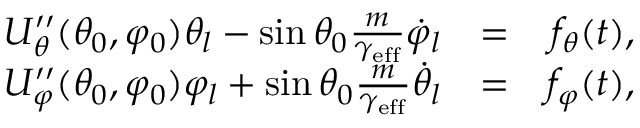<formula> <loc_0><loc_0><loc_500><loc_500>\begin{array} { r l r } { U _ { \theta } ^ { \prime \prime } ( \theta _ { 0 } , \varphi _ { 0 } ) \theta _ { l } - \sin \theta _ { 0 } \frac { m } { \gamma _ { e f f } } \dot { \varphi } _ { l } } & { = } & { f _ { \theta } ( t ) , } \\ { U _ { \varphi } ^ { \prime \prime } ( \theta _ { 0 } , \varphi _ { 0 } ) \varphi _ { l } + \sin \theta _ { 0 } \frac { m } { \gamma _ { e f f } } \dot { \theta } _ { l } } & { = } & { f _ { \varphi } ( t ) , } \end{array}</formula> 